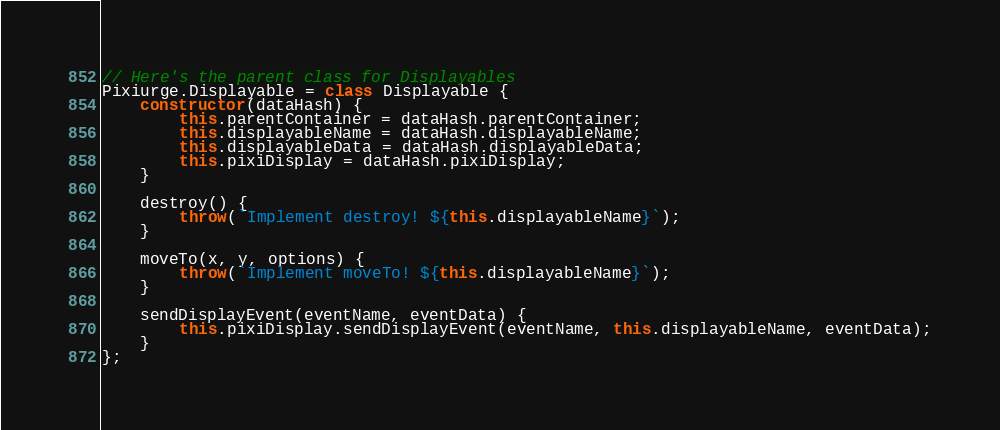<code> <loc_0><loc_0><loc_500><loc_500><_JavaScript_>// Here's the parent class for Displayables
Pixiurge.Displayable = class Displayable {
    constructor(dataHash) {
        this.parentContainer = dataHash.parentContainer;
        this.displayableName = dataHash.displayableName;
        this.displayableData = dataHash.displayableData;
        this.pixiDisplay = dataHash.pixiDisplay;
    }

    destroy() {
        throw(`Implement destroy! ${this.displayableName}`);
    }

    moveTo(x, y, options) {
        throw(`Implement moveTo! ${this.displayableName}`);
    }

    sendDisplayEvent(eventName, eventData) {
        this.pixiDisplay.sendDisplayEvent(eventName, this.displayableName, eventData);
    }
};
</code> 